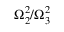Convert formula to latex. <formula><loc_0><loc_0><loc_500><loc_500>\Omega _ { 2 } ^ { 2 } / \Omega _ { 3 } ^ { 2 }</formula> 